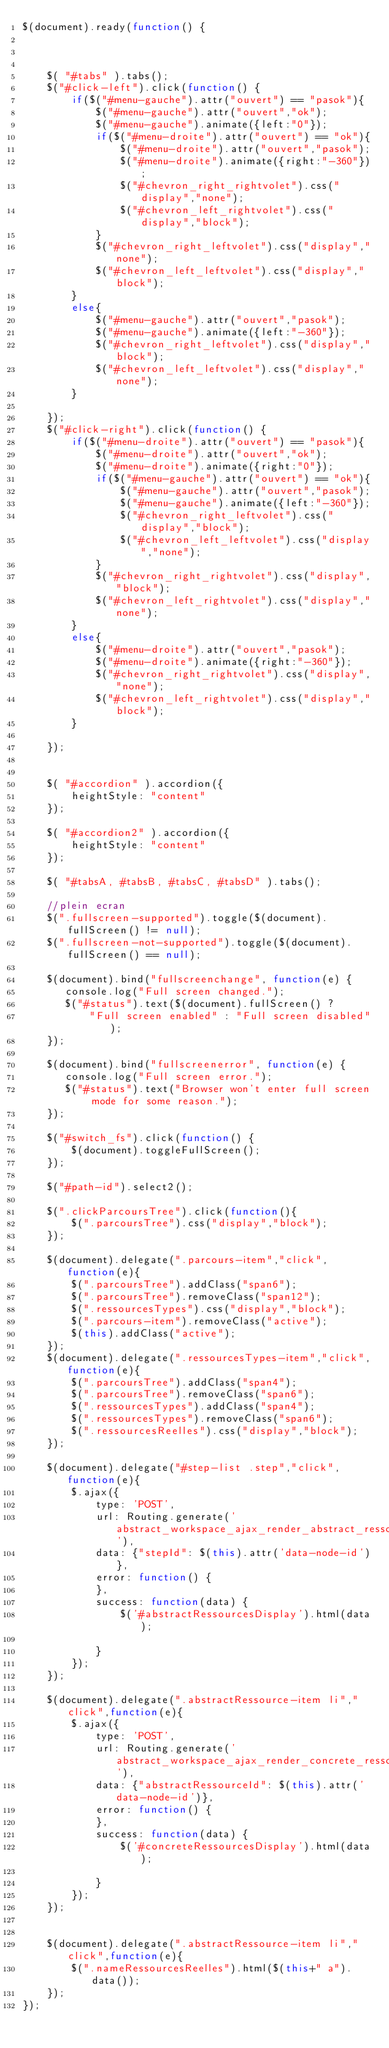<code> <loc_0><loc_0><loc_500><loc_500><_JavaScript_>$(document).ready(function() {



    $( "#tabs" ).tabs();
    $("#click-left").click(function() {
        if($("#menu-gauche").attr("ouvert") == "pasok"){
            $("#menu-gauche").attr("ouvert","ok");
            $("#menu-gauche").animate({left:"0"});
            if($("#menu-droite").attr("ouvert") == "ok"){
                $("#menu-droite").attr("ouvert","pasok");
                $("#menu-droite").animate({right:"-360"});
                $("#chevron_right_rightvolet").css("display","none");
                $("#chevron_left_rightvolet").css("display","block");
            }
            $("#chevron_right_leftvolet").css("display","none");
            $("#chevron_left_leftvolet").css("display","block");
        }
        else{
            $("#menu-gauche").attr("ouvert","pasok");
            $("#menu-gauche").animate({left:"-360"});
            $("#chevron_right_leftvolet").css("display","block");
            $("#chevron_left_leftvolet").css("display","none");
        }

    });
    $("#click-right").click(function() {
        if($("#menu-droite").attr("ouvert") == "pasok"){
            $("#menu-droite").attr("ouvert","ok");
            $("#menu-droite").animate({right:"0"});
            if($("#menu-gauche").attr("ouvert") == "ok"){
                $("#menu-gauche").attr("ouvert","pasok");
                $("#menu-gauche").animate({left:"-360"});
                $("#chevron_right_leftvolet").css("display","block");
                $("#chevron_left_leftvolet").css("display","none");
            }
            $("#chevron_right_rightvolet").css("display","block");
            $("#chevron_left_rightvolet").css("display","none");
        }
        else{
            $("#menu-droite").attr("ouvert","pasok");
            $("#menu-droite").animate({right:"-360"});
            $("#chevron_right_rightvolet").css("display","none");
            $("#chevron_left_rightvolet").css("display","block");
        }

    });


    $( "#accordion" ).accordion({
        heightStyle: "content"
    });

    $( "#accordion2" ).accordion({
        heightStyle: "content"
    });

    $( "#tabsA, #tabsB, #tabsC, #tabsD" ).tabs();

    //plein ecran
    $(".fullscreen-supported").toggle($(document).fullScreen() != null);
    $(".fullscreen-not-supported").toggle($(document).fullScreen() == null);

    $(document).bind("fullscreenchange", function(e) {
       console.log("Full screen changed.");
       $("#status").text($(document).fullScreen() ?
           "Full screen enabled" : "Full screen disabled");
    });

    $(document).bind("fullscreenerror", function(e) {
       console.log("Full screen error.");
       $("#status").text("Browser won't enter full screen mode for some reason.");
    });

    $("#switch_fs").click(function() {
        $(document).toggleFullScreen();
    });

    $("#path-id").select2(); 

    $(".clickParcoursTree").click(function(){
        $(".parcoursTree").css("display","block");
    });

    $(document).delegate(".parcours-item","click",function(e){
        $(".parcoursTree").addClass("span6");
        $(".parcoursTree").removeClass("span12");
        $(".ressourcesTypes").css("display","block");
        $(".parcours-item").removeClass("active");
        $(this).addClass("active");
    });
    $(document).delegate(".ressourcesTypes-item","click",function(e){
        $(".parcoursTree").addClass("span4");
        $(".parcoursTree").removeClass("span6");
        $(".ressourcesTypes").addClass("span4");
        $(".ressourcesTypes").removeClass("span6");
        $(".ressourcesReelles").css("display","block");
    });

    $(document).delegate("#step-list .step","click",function(e){
        $.ajax({
            type: 'POST',
            url: Routing.generate('abstract_workspace_ajax_render_abstract_ressource'),
            data: {"stepId": $(this).attr('data-node-id')},
            error: function() { 
            },
            success: function(data) {
                $('#abstractRessourcesDisplay').html(data);

            }
        });
    });

    $(document).delegate(".abstractRessource-item li","click",function(e){
        $.ajax({
            type: 'POST',
            url: Routing.generate('abstract_workspace_ajax_render_concrete_ressource'),
            data: {"abstractRessourceId": $(this).attr('data-node-id')},
            error: function() { 
            },
            success: function(data) {
                $('#concreteRessourcesDisplay').html(data);

            }
        });
    });

    
    $(document).delegate(".abstractRessource-item li","click",function(e){
        $(".nameRessourcesReelles").html($(this+" a").data());
    });
});
</code> 